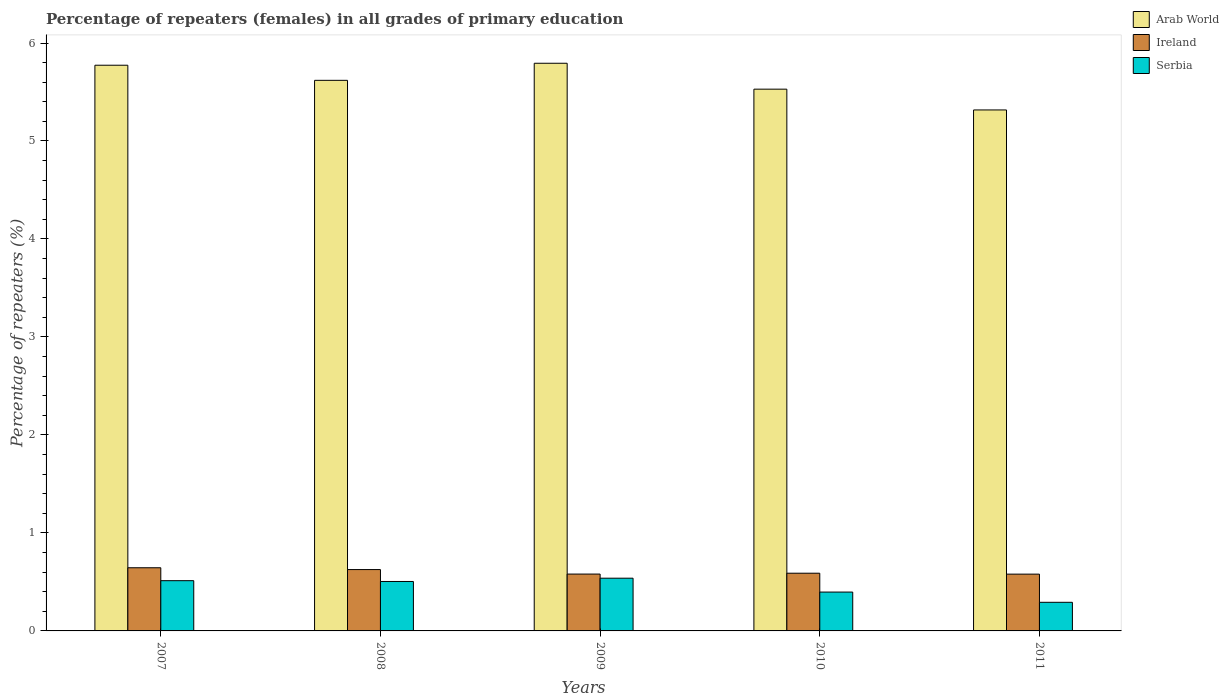How many different coloured bars are there?
Make the answer very short. 3. How many groups of bars are there?
Provide a succinct answer. 5. How many bars are there on the 4th tick from the left?
Provide a succinct answer. 3. In how many cases, is the number of bars for a given year not equal to the number of legend labels?
Make the answer very short. 0. What is the percentage of repeaters (females) in Serbia in 2010?
Offer a very short reply. 0.4. Across all years, what is the maximum percentage of repeaters (females) in Arab World?
Keep it short and to the point. 5.79. Across all years, what is the minimum percentage of repeaters (females) in Serbia?
Your response must be concise. 0.29. What is the total percentage of repeaters (females) in Arab World in the graph?
Give a very brief answer. 28.03. What is the difference between the percentage of repeaters (females) in Arab World in 2007 and that in 2010?
Provide a short and direct response. 0.24. What is the difference between the percentage of repeaters (females) in Ireland in 2007 and the percentage of repeaters (females) in Arab World in 2011?
Provide a short and direct response. -4.67. What is the average percentage of repeaters (females) in Ireland per year?
Ensure brevity in your answer.  0.6. In the year 2008, what is the difference between the percentage of repeaters (females) in Ireland and percentage of repeaters (females) in Arab World?
Your answer should be very brief. -4.99. What is the ratio of the percentage of repeaters (females) in Serbia in 2007 to that in 2008?
Offer a very short reply. 1.02. Is the difference between the percentage of repeaters (females) in Ireland in 2010 and 2011 greater than the difference between the percentage of repeaters (females) in Arab World in 2010 and 2011?
Offer a terse response. No. What is the difference between the highest and the second highest percentage of repeaters (females) in Ireland?
Provide a succinct answer. 0.02. What is the difference between the highest and the lowest percentage of repeaters (females) in Ireland?
Keep it short and to the point. 0.07. What does the 3rd bar from the left in 2008 represents?
Your answer should be very brief. Serbia. What does the 2nd bar from the right in 2011 represents?
Give a very brief answer. Ireland. How many bars are there?
Offer a very short reply. 15. How many years are there in the graph?
Your response must be concise. 5. What is the difference between two consecutive major ticks on the Y-axis?
Your response must be concise. 1. Are the values on the major ticks of Y-axis written in scientific E-notation?
Your response must be concise. No. Does the graph contain any zero values?
Offer a terse response. No. Where does the legend appear in the graph?
Offer a terse response. Top right. How are the legend labels stacked?
Give a very brief answer. Vertical. What is the title of the graph?
Give a very brief answer. Percentage of repeaters (females) in all grades of primary education. Does "Germany" appear as one of the legend labels in the graph?
Your answer should be compact. No. What is the label or title of the X-axis?
Give a very brief answer. Years. What is the label or title of the Y-axis?
Ensure brevity in your answer.  Percentage of repeaters (%). What is the Percentage of repeaters (%) of Arab World in 2007?
Ensure brevity in your answer.  5.77. What is the Percentage of repeaters (%) in Ireland in 2007?
Your answer should be compact. 0.64. What is the Percentage of repeaters (%) in Serbia in 2007?
Offer a very short reply. 0.51. What is the Percentage of repeaters (%) in Arab World in 2008?
Offer a very short reply. 5.62. What is the Percentage of repeaters (%) in Ireland in 2008?
Ensure brevity in your answer.  0.63. What is the Percentage of repeaters (%) in Serbia in 2008?
Provide a succinct answer. 0.5. What is the Percentage of repeaters (%) in Arab World in 2009?
Offer a very short reply. 5.79. What is the Percentage of repeaters (%) of Ireland in 2009?
Your answer should be very brief. 0.58. What is the Percentage of repeaters (%) in Serbia in 2009?
Provide a succinct answer. 0.54. What is the Percentage of repeaters (%) in Arab World in 2010?
Your answer should be very brief. 5.53. What is the Percentage of repeaters (%) in Ireland in 2010?
Your response must be concise. 0.59. What is the Percentage of repeaters (%) of Serbia in 2010?
Offer a terse response. 0.4. What is the Percentage of repeaters (%) of Arab World in 2011?
Your response must be concise. 5.32. What is the Percentage of repeaters (%) in Ireland in 2011?
Your answer should be compact. 0.58. What is the Percentage of repeaters (%) of Serbia in 2011?
Make the answer very short. 0.29. Across all years, what is the maximum Percentage of repeaters (%) of Arab World?
Offer a terse response. 5.79. Across all years, what is the maximum Percentage of repeaters (%) of Ireland?
Make the answer very short. 0.64. Across all years, what is the maximum Percentage of repeaters (%) in Serbia?
Your answer should be very brief. 0.54. Across all years, what is the minimum Percentage of repeaters (%) of Arab World?
Your response must be concise. 5.32. Across all years, what is the minimum Percentage of repeaters (%) in Ireland?
Your answer should be very brief. 0.58. Across all years, what is the minimum Percentage of repeaters (%) of Serbia?
Make the answer very short. 0.29. What is the total Percentage of repeaters (%) in Arab World in the graph?
Your answer should be compact. 28.03. What is the total Percentage of repeaters (%) of Ireland in the graph?
Your answer should be very brief. 3.02. What is the total Percentage of repeaters (%) of Serbia in the graph?
Provide a succinct answer. 2.24. What is the difference between the Percentage of repeaters (%) in Arab World in 2007 and that in 2008?
Ensure brevity in your answer.  0.15. What is the difference between the Percentage of repeaters (%) in Ireland in 2007 and that in 2008?
Give a very brief answer. 0.02. What is the difference between the Percentage of repeaters (%) of Serbia in 2007 and that in 2008?
Your answer should be compact. 0.01. What is the difference between the Percentage of repeaters (%) in Arab World in 2007 and that in 2009?
Keep it short and to the point. -0.02. What is the difference between the Percentage of repeaters (%) in Ireland in 2007 and that in 2009?
Provide a short and direct response. 0.06. What is the difference between the Percentage of repeaters (%) in Serbia in 2007 and that in 2009?
Make the answer very short. -0.03. What is the difference between the Percentage of repeaters (%) of Arab World in 2007 and that in 2010?
Keep it short and to the point. 0.24. What is the difference between the Percentage of repeaters (%) in Ireland in 2007 and that in 2010?
Ensure brevity in your answer.  0.06. What is the difference between the Percentage of repeaters (%) of Serbia in 2007 and that in 2010?
Your answer should be compact. 0.12. What is the difference between the Percentage of repeaters (%) in Arab World in 2007 and that in 2011?
Keep it short and to the point. 0.46. What is the difference between the Percentage of repeaters (%) of Ireland in 2007 and that in 2011?
Offer a terse response. 0.07. What is the difference between the Percentage of repeaters (%) of Serbia in 2007 and that in 2011?
Your response must be concise. 0.22. What is the difference between the Percentage of repeaters (%) in Arab World in 2008 and that in 2009?
Your answer should be very brief. -0.17. What is the difference between the Percentage of repeaters (%) in Ireland in 2008 and that in 2009?
Offer a terse response. 0.05. What is the difference between the Percentage of repeaters (%) in Serbia in 2008 and that in 2009?
Give a very brief answer. -0.03. What is the difference between the Percentage of repeaters (%) of Arab World in 2008 and that in 2010?
Make the answer very short. 0.09. What is the difference between the Percentage of repeaters (%) in Ireland in 2008 and that in 2010?
Offer a terse response. 0.04. What is the difference between the Percentage of repeaters (%) of Serbia in 2008 and that in 2010?
Offer a terse response. 0.11. What is the difference between the Percentage of repeaters (%) in Arab World in 2008 and that in 2011?
Your response must be concise. 0.3. What is the difference between the Percentage of repeaters (%) in Ireland in 2008 and that in 2011?
Offer a very short reply. 0.05. What is the difference between the Percentage of repeaters (%) in Serbia in 2008 and that in 2011?
Ensure brevity in your answer.  0.21. What is the difference between the Percentage of repeaters (%) of Arab World in 2009 and that in 2010?
Ensure brevity in your answer.  0.26. What is the difference between the Percentage of repeaters (%) in Ireland in 2009 and that in 2010?
Provide a short and direct response. -0.01. What is the difference between the Percentage of repeaters (%) of Serbia in 2009 and that in 2010?
Give a very brief answer. 0.14. What is the difference between the Percentage of repeaters (%) in Arab World in 2009 and that in 2011?
Your answer should be very brief. 0.48. What is the difference between the Percentage of repeaters (%) of Ireland in 2009 and that in 2011?
Ensure brevity in your answer.  0. What is the difference between the Percentage of repeaters (%) in Serbia in 2009 and that in 2011?
Keep it short and to the point. 0.25. What is the difference between the Percentage of repeaters (%) of Arab World in 2010 and that in 2011?
Offer a terse response. 0.21. What is the difference between the Percentage of repeaters (%) of Ireland in 2010 and that in 2011?
Offer a terse response. 0.01. What is the difference between the Percentage of repeaters (%) in Serbia in 2010 and that in 2011?
Provide a short and direct response. 0.1. What is the difference between the Percentage of repeaters (%) in Arab World in 2007 and the Percentage of repeaters (%) in Ireland in 2008?
Your answer should be very brief. 5.15. What is the difference between the Percentage of repeaters (%) of Arab World in 2007 and the Percentage of repeaters (%) of Serbia in 2008?
Offer a very short reply. 5.27. What is the difference between the Percentage of repeaters (%) of Ireland in 2007 and the Percentage of repeaters (%) of Serbia in 2008?
Give a very brief answer. 0.14. What is the difference between the Percentage of repeaters (%) of Arab World in 2007 and the Percentage of repeaters (%) of Ireland in 2009?
Ensure brevity in your answer.  5.19. What is the difference between the Percentage of repeaters (%) in Arab World in 2007 and the Percentage of repeaters (%) in Serbia in 2009?
Keep it short and to the point. 5.24. What is the difference between the Percentage of repeaters (%) of Ireland in 2007 and the Percentage of repeaters (%) of Serbia in 2009?
Ensure brevity in your answer.  0.11. What is the difference between the Percentage of repeaters (%) in Arab World in 2007 and the Percentage of repeaters (%) in Ireland in 2010?
Give a very brief answer. 5.18. What is the difference between the Percentage of repeaters (%) in Arab World in 2007 and the Percentage of repeaters (%) in Serbia in 2010?
Offer a terse response. 5.38. What is the difference between the Percentage of repeaters (%) in Ireland in 2007 and the Percentage of repeaters (%) in Serbia in 2010?
Make the answer very short. 0.25. What is the difference between the Percentage of repeaters (%) of Arab World in 2007 and the Percentage of repeaters (%) of Ireland in 2011?
Offer a very short reply. 5.19. What is the difference between the Percentage of repeaters (%) in Arab World in 2007 and the Percentage of repeaters (%) in Serbia in 2011?
Provide a short and direct response. 5.48. What is the difference between the Percentage of repeaters (%) in Ireland in 2007 and the Percentage of repeaters (%) in Serbia in 2011?
Offer a terse response. 0.35. What is the difference between the Percentage of repeaters (%) of Arab World in 2008 and the Percentage of repeaters (%) of Ireland in 2009?
Keep it short and to the point. 5.04. What is the difference between the Percentage of repeaters (%) of Arab World in 2008 and the Percentage of repeaters (%) of Serbia in 2009?
Give a very brief answer. 5.08. What is the difference between the Percentage of repeaters (%) of Ireland in 2008 and the Percentage of repeaters (%) of Serbia in 2009?
Give a very brief answer. 0.09. What is the difference between the Percentage of repeaters (%) in Arab World in 2008 and the Percentage of repeaters (%) in Ireland in 2010?
Your response must be concise. 5.03. What is the difference between the Percentage of repeaters (%) of Arab World in 2008 and the Percentage of repeaters (%) of Serbia in 2010?
Provide a short and direct response. 5.22. What is the difference between the Percentage of repeaters (%) of Ireland in 2008 and the Percentage of repeaters (%) of Serbia in 2010?
Your answer should be very brief. 0.23. What is the difference between the Percentage of repeaters (%) in Arab World in 2008 and the Percentage of repeaters (%) in Ireland in 2011?
Provide a short and direct response. 5.04. What is the difference between the Percentage of repeaters (%) of Arab World in 2008 and the Percentage of repeaters (%) of Serbia in 2011?
Offer a very short reply. 5.33. What is the difference between the Percentage of repeaters (%) of Ireland in 2008 and the Percentage of repeaters (%) of Serbia in 2011?
Your answer should be compact. 0.33. What is the difference between the Percentage of repeaters (%) of Arab World in 2009 and the Percentage of repeaters (%) of Ireland in 2010?
Keep it short and to the point. 5.2. What is the difference between the Percentage of repeaters (%) in Arab World in 2009 and the Percentage of repeaters (%) in Serbia in 2010?
Ensure brevity in your answer.  5.4. What is the difference between the Percentage of repeaters (%) of Ireland in 2009 and the Percentage of repeaters (%) of Serbia in 2010?
Your answer should be very brief. 0.18. What is the difference between the Percentage of repeaters (%) in Arab World in 2009 and the Percentage of repeaters (%) in Ireland in 2011?
Provide a short and direct response. 5.21. What is the difference between the Percentage of repeaters (%) in Arab World in 2009 and the Percentage of repeaters (%) in Serbia in 2011?
Offer a very short reply. 5.5. What is the difference between the Percentage of repeaters (%) of Ireland in 2009 and the Percentage of repeaters (%) of Serbia in 2011?
Ensure brevity in your answer.  0.29. What is the difference between the Percentage of repeaters (%) of Arab World in 2010 and the Percentage of repeaters (%) of Ireland in 2011?
Make the answer very short. 4.95. What is the difference between the Percentage of repeaters (%) of Arab World in 2010 and the Percentage of repeaters (%) of Serbia in 2011?
Make the answer very short. 5.24. What is the difference between the Percentage of repeaters (%) in Ireland in 2010 and the Percentage of repeaters (%) in Serbia in 2011?
Offer a terse response. 0.3. What is the average Percentage of repeaters (%) of Arab World per year?
Offer a very short reply. 5.61. What is the average Percentage of repeaters (%) of Ireland per year?
Your answer should be very brief. 0.6. What is the average Percentage of repeaters (%) of Serbia per year?
Provide a short and direct response. 0.45. In the year 2007, what is the difference between the Percentage of repeaters (%) in Arab World and Percentage of repeaters (%) in Ireland?
Offer a very short reply. 5.13. In the year 2007, what is the difference between the Percentage of repeaters (%) in Arab World and Percentage of repeaters (%) in Serbia?
Offer a very short reply. 5.26. In the year 2007, what is the difference between the Percentage of repeaters (%) in Ireland and Percentage of repeaters (%) in Serbia?
Provide a short and direct response. 0.13. In the year 2008, what is the difference between the Percentage of repeaters (%) of Arab World and Percentage of repeaters (%) of Ireland?
Offer a very short reply. 4.99. In the year 2008, what is the difference between the Percentage of repeaters (%) of Arab World and Percentage of repeaters (%) of Serbia?
Your answer should be compact. 5.11. In the year 2008, what is the difference between the Percentage of repeaters (%) of Ireland and Percentage of repeaters (%) of Serbia?
Your answer should be very brief. 0.12. In the year 2009, what is the difference between the Percentage of repeaters (%) in Arab World and Percentage of repeaters (%) in Ireland?
Ensure brevity in your answer.  5.21. In the year 2009, what is the difference between the Percentage of repeaters (%) in Arab World and Percentage of repeaters (%) in Serbia?
Provide a succinct answer. 5.26. In the year 2009, what is the difference between the Percentage of repeaters (%) of Ireland and Percentage of repeaters (%) of Serbia?
Your response must be concise. 0.04. In the year 2010, what is the difference between the Percentage of repeaters (%) of Arab World and Percentage of repeaters (%) of Ireland?
Make the answer very short. 4.94. In the year 2010, what is the difference between the Percentage of repeaters (%) in Arab World and Percentage of repeaters (%) in Serbia?
Your response must be concise. 5.13. In the year 2010, what is the difference between the Percentage of repeaters (%) in Ireland and Percentage of repeaters (%) in Serbia?
Provide a short and direct response. 0.19. In the year 2011, what is the difference between the Percentage of repeaters (%) of Arab World and Percentage of repeaters (%) of Ireland?
Your response must be concise. 4.74. In the year 2011, what is the difference between the Percentage of repeaters (%) in Arab World and Percentage of repeaters (%) in Serbia?
Your answer should be very brief. 5.02. In the year 2011, what is the difference between the Percentage of repeaters (%) of Ireland and Percentage of repeaters (%) of Serbia?
Your response must be concise. 0.29. What is the ratio of the Percentage of repeaters (%) of Arab World in 2007 to that in 2008?
Your response must be concise. 1.03. What is the ratio of the Percentage of repeaters (%) of Ireland in 2007 to that in 2008?
Your answer should be compact. 1.03. What is the ratio of the Percentage of repeaters (%) in Serbia in 2007 to that in 2008?
Make the answer very short. 1.02. What is the ratio of the Percentage of repeaters (%) in Arab World in 2007 to that in 2009?
Offer a terse response. 1. What is the ratio of the Percentage of repeaters (%) of Ireland in 2007 to that in 2009?
Ensure brevity in your answer.  1.11. What is the ratio of the Percentage of repeaters (%) of Serbia in 2007 to that in 2009?
Make the answer very short. 0.95. What is the ratio of the Percentage of repeaters (%) of Arab World in 2007 to that in 2010?
Offer a terse response. 1.04. What is the ratio of the Percentage of repeaters (%) in Ireland in 2007 to that in 2010?
Your answer should be very brief. 1.09. What is the ratio of the Percentage of repeaters (%) in Serbia in 2007 to that in 2010?
Offer a terse response. 1.29. What is the ratio of the Percentage of repeaters (%) of Arab World in 2007 to that in 2011?
Your answer should be compact. 1.09. What is the ratio of the Percentage of repeaters (%) of Ireland in 2007 to that in 2011?
Provide a succinct answer. 1.11. What is the ratio of the Percentage of repeaters (%) in Serbia in 2007 to that in 2011?
Your answer should be very brief. 1.76. What is the ratio of the Percentage of repeaters (%) in Arab World in 2008 to that in 2009?
Offer a very short reply. 0.97. What is the ratio of the Percentage of repeaters (%) in Ireland in 2008 to that in 2009?
Provide a succinct answer. 1.08. What is the ratio of the Percentage of repeaters (%) in Serbia in 2008 to that in 2009?
Offer a terse response. 0.94. What is the ratio of the Percentage of repeaters (%) of Arab World in 2008 to that in 2010?
Your response must be concise. 1.02. What is the ratio of the Percentage of repeaters (%) of Ireland in 2008 to that in 2010?
Your answer should be very brief. 1.06. What is the ratio of the Percentage of repeaters (%) in Serbia in 2008 to that in 2010?
Make the answer very short. 1.27. What is the ratio of the Percentage of repeaters (%) of Arab World in 2008 to that in 2011?
Provide a succinct answer. 1.06. What is the ratio of the Percentage of repeaters (%) of Ireland in 2008 to that in 2011?
Offer a very short reply. 1.08. What is the ratio of the Percentage of repeaters (%) of Serbia in 2008 to that in 2011?
Ensure brevity in your answer.  1.73. What is the ratio of the Percentage of repeaters (%) of Arab World in 2009 to that in 2010?
Make the answer very short. 1.05. What is the ratio of the Percentage of repeaters (%) in Ireland in 2009 to that in 2010?
Offer a very short reply. 0.99. What is the ratio of the Percentage of repeaters (%) in Serbia in 2009 to that in 2010?
Ensure brevity in your answer.  1.36. What is the ratio of the Percentage of repeaters (%) in Arab World in 2009 to that in 2011?
Offer a very short reply. 1.09. What is the ratio of the Percentage of repeaters (%) of Ireland in 2009 to that in 2011?
Provide a short and direct response. 1. What is the ratio of the Percentage of repeaters (%) of Serbia in 2009 to that in 2011?
Offer a very short reply. 1.84. What is the ratio of the Percentage of repeaters (%) of Arab World in 2010 to that in 2011?
Keep it short and to the point. 1.04. What is the ratio of the Percentage of repeaters (%) of Ireland in 2010 to that in 2011?
Offer a terse response. 1.02. What is the ratio of the Percentage of repeaters (%) in Serbia in 2010 to that in 2011?
Your answer should be very brief. 1.36. What is the difference between the highest and the second highest Percentage of repeaters (%) in Arab World?
Give a very brief answer. 0.02. What is the difference between the highest and the second highest Percentage of repeaters (%) in Ireland?
Give a very brief answer. 0.02. What is the difference between the highest and the second highest Percentage of repeaters (%) in Serbia?
Provide a short and direct response. 0.03. What is the difference between the highest and the lowest Percentage of repeaters (%) of Arab World?
Offer a very short reply. 0.48. What is the difference between the highest and the lowest Percentage of repeaters (%) of Ireland?
Provide a short and direct response. 0.07. What is the difference between the highest and the lowest Percentage of repeaters (%) in Serbia?
Provide a succinct answer. 0.25. 